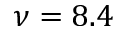<formula> <loc_0><loc_0><loc_500><loc_500>\nu = 8 . 4</formula> 